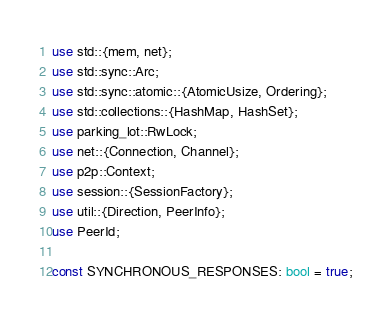Convert code to text. <code><loc_0><loc_0><loc_500><loc_500><_Rust_>use std::{mem, net};
use std::sync::Arc;
use std::sync::atomic::{AtomicUsize, Ordering};
use std::collections::{HashMap, HashSet};
use parking_lot::RwLock;
use net::{Connection, Channel};
use p2p::Context;
use session::{SessionFactory};
use util::{Direction, PeerInfo};
use PeerId;

const SYNCHRONOUS_RESPONSES: bool = true;
</code> 